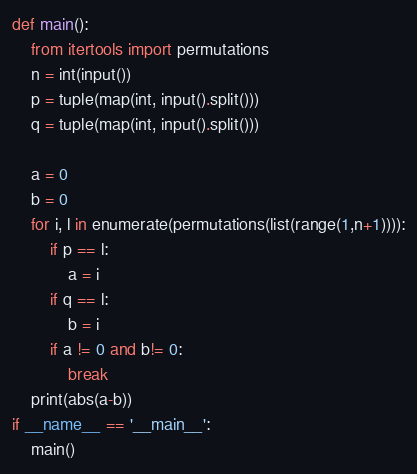Convert code to text. <code><loc_0><loc_0><loc_500><loc_500><_Python_>def main():
    from itertools import permutations
    n = int(input())
    p = tuple(map(int, input().split()))
    q = tuple(map(int, input().split()))

    a = 0
    b = 0
    for i, l in enumerate(permutations(list(range(1,n+1)))):
        if p == l:
            a = i
        if q == l:
            b = i
        if a != 0 and b!= 0:
            break
    print(abs(a-b))
if __name__ == '__main__':
    main()
</code> 